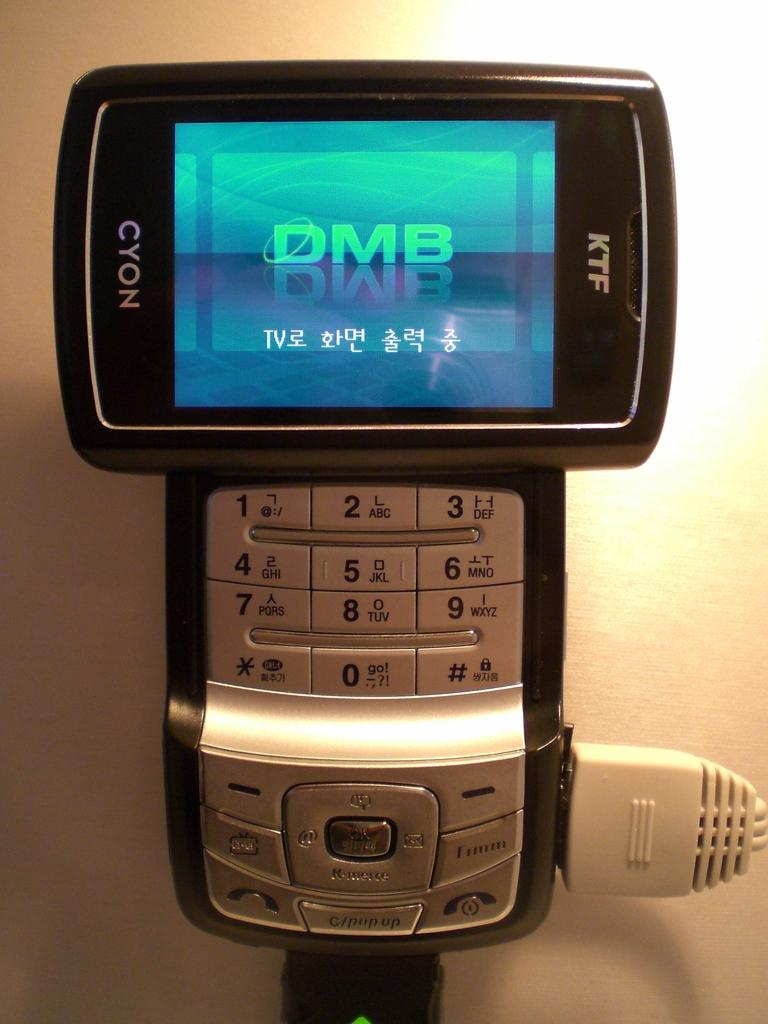<image>
Give a short and clear explanation of the subsequent image. KTF Cyon cellphone being put on display with a cord connected. 